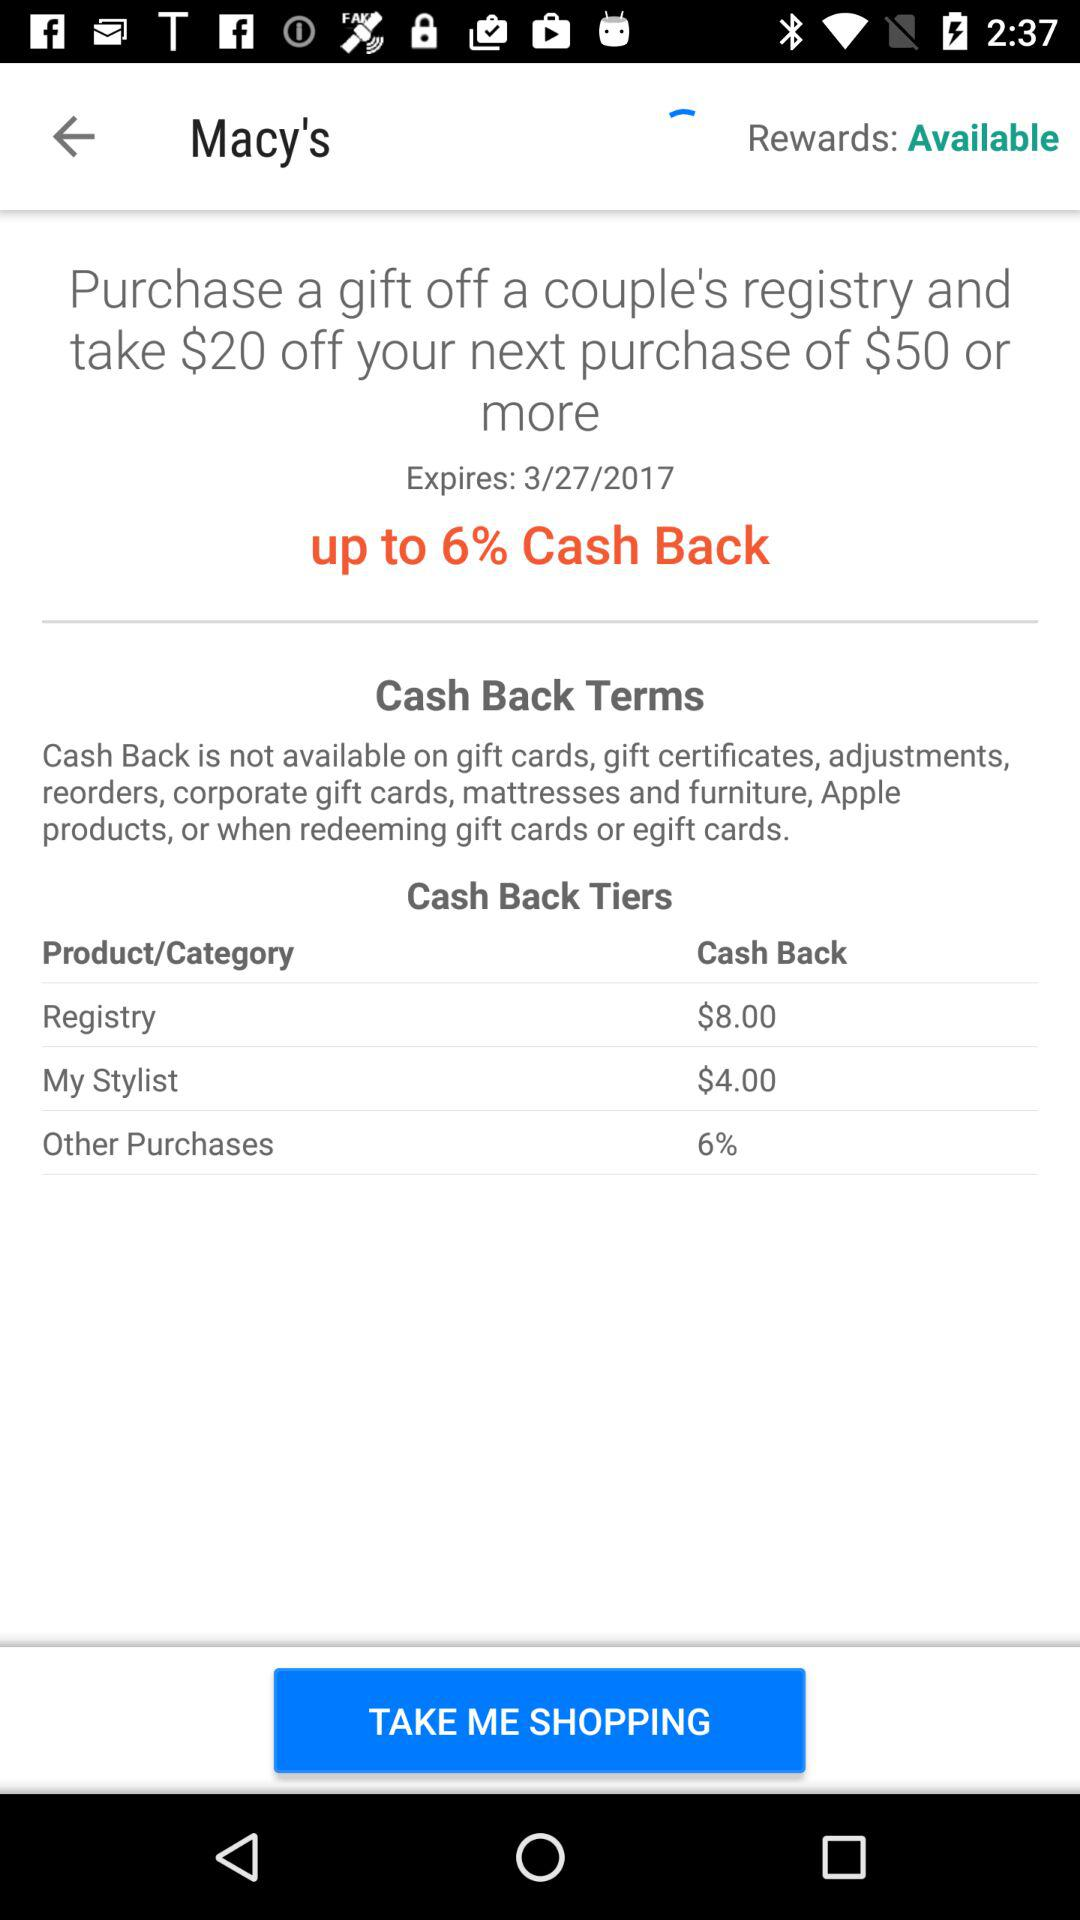When will the deal expire? The deal will expire on March 27, 2017. 